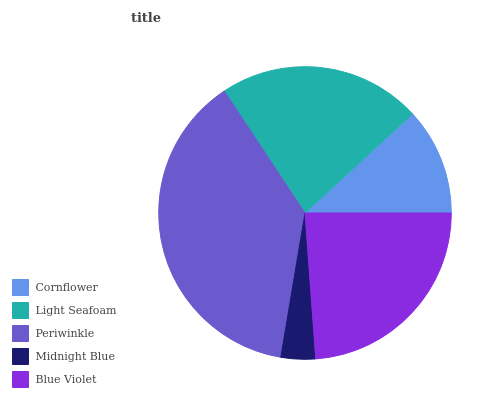Is Midnight Blue the minimum?
Answer yes or no. Yes. Is Periwinkle the maximum?
Answer yes or no. Yes. Is Light Seafoam the minimum?
Answer yes or no. No. Is Light Seafoam the maximum?
Answer yes or no. No. Is Light Seafoam greater than Cornflower?
Answer yes or no. Yes. Is Cornflower less than Light Seafoam?
Answer yes or no. Yes. Is Cornflower greater than Light Seafoam?
Answer yes or no. No. Is Light Seafoam less than Cornflower?
Answer yes or no. No. Is Light Seafoam the high median?
Answer yes or no. Yes. Is Light Seafoam the low median?
Answer yes or no. Yes. Is Midnight Blue the high median?
Answer yes or no. No. Is Midnight Blue the low median?
Answer yes or no. No. 